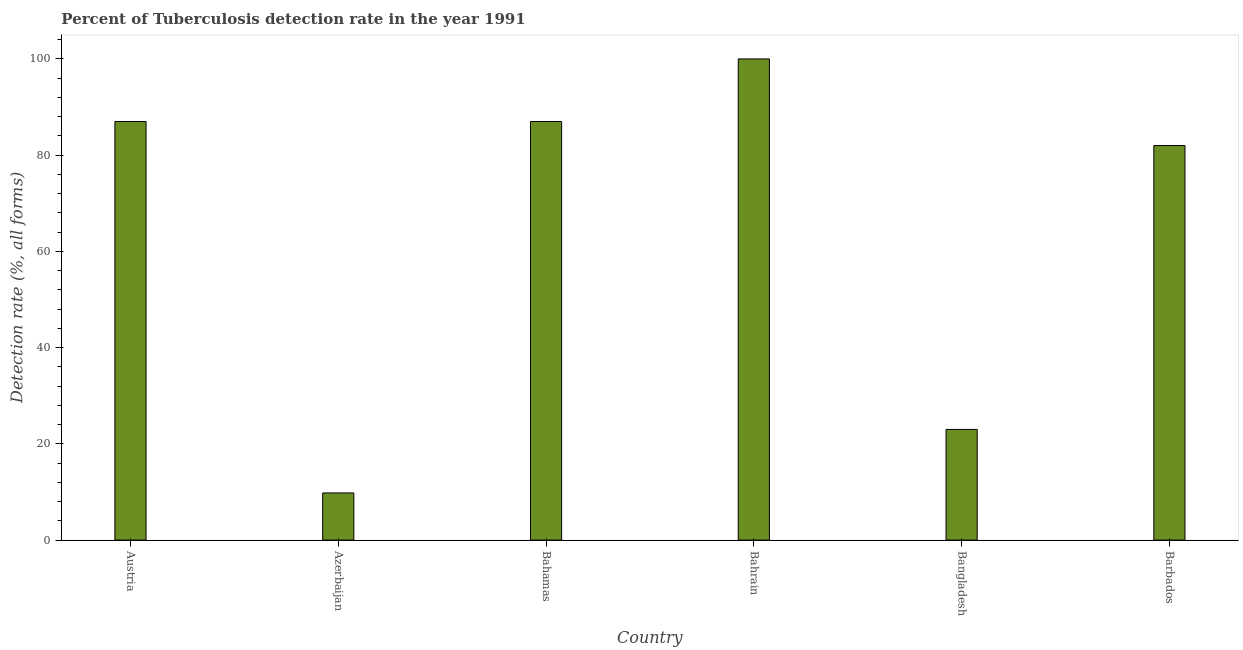What is the title of the graph?
Offer a very short reply. Percent of Tuberculosis detection rate in the year 1991. What is the label or title of the X-axis?
Provide a succinct answer. Country. What is the label or title of the Y-axis?
Ensure brevity in your answer.  Detection rate (%, all forms). Across all countries, what is the maximum detection rate of tuberculosis?
Give a very brief answer. 100. Across all countries, what is the minimum detection rate of tuberculosis?
Your response must be concise. 9.8. In which country was the detection rate of tuberculosis maximum?
Your answer should be very brief. Bahrain. In which country was the detection rate of tuberculosis minimum?
Your answer should be compact. Azerbaijan. What is the sum of the detection rate of tuberculosis?
Provide a succinct answer. 388.8. What is the difference between the detection rate of tuberculosis in Bahamas and Barbados?
Offer a very short reply. 5. What is the average detection rate of tuberculosis per country?
Make the answer very short. 64.8. What is the median detection rate of tuberculosis?
Offer a terse response. 84.5. In how many countries, is the detection rate of tuberculosis greater than 80 %?
Ensure brevity in your answer.  4. What is the ratio of the detection rate of tuberculosis in Bahamas to that in Barbados?
Your response must be concise. 1.06. Is the detection rate of tuberculosis in Azerbaijan less than that in Bahamas?
Make the answer very short. Yes. Is the difference between the detection rate of tuberculosis in Bahamas and Barbados greater than the difference between any two countries?
Provide a short and direct response. No. What is the difference between the highest and the second highest detection rate of tuberculosis?
Your answer should be very brief. 13. What is the difference between the highest and the lowest detection rate of tuberculosis?
Ensure brevity in your answer.  90.2. How many bars are there?
Offer a very short reply. 6. Are all the bars in the graph horizontal?
Provide a succinct answer. No. What is the Detection rate (%, all forms) of Bahamas?
Your response must be concise. 87. What is the Detection rate (%, all forms) of Bahrain?
Your answer should be very brief. 100. What is the difference between the Detection rate (%, all forms) in Austria and Azerbaijan?
Keep it short and to the point. 77.2. What is the difference between the Detection rate (%, all forms) in Austria and Bahrain?
Ensure brevity in your answer.  -13. What is the difference between the Detection rate (%, all forms) in Austria and Bangladesh?
Ensure brevity in your answer.  64. What is the difference between the Detection rate (%, all forms) in Austria and Barbados?
Provide a short and direct response. 5. What is the difference between the Detection rate (%, all forms) in Azerbaijan and Bahamas?
Offer a very short reply. -77.2. What is the difference between the Detection rate (%, all forms) in Azerbaijan and Bahrain?
Give a very brief answer. -90.2. What is the difference between the Detection rate (%, all forms) in Azerbaijan and Bangladesh?
Keep it short and to the point. -13.2. What is the difference between the Detection rate (%, all forms) in Azerbaijan and Barbados?
Your response must be concise. -72.2. What is the difference between the Detection rate (%, all forms) in Bahamas and Bahrain?
Give a very brief answer. -13. What is the difference between the Detection rate (%, all forms) in Bahrain and Bangladesh?
Provide a succinct answer. 77. What is the difference between the Detection rate (%, all forms) in Bangladesh and Barbados?
Make the answer very short. -59. What is the ratio of the Detection rate (%, all forms) in Austria to that in Azerbaijan?
Ensure brevity in your answer.  8.88. What is the ratio of the Detection rate (%, all forms) in Austria to that in Bahrain?
Offer a terse response. 0.87. What is the ratio of the Detection rate (%, all forms) in Austria to that in Bangladesh?
Ensure brevity in your answer.  3.78. What is the ratio of the Detection rate (%, all forms) in Austria to that in Barbados?
Give a very brief answer. 1.06. What is the ratio of the Detection rate (%, all forms) in Azerbaijan to that in Bahamas?
Keep it short and to the point. 0.11. What is the ratio of the Detection rate (%, all forms) in Azerbaijan to that in Bahrain?
Ensure brevity in your answer.  0.1. What is the ratio of the Detection rate (%, all forms) in Azerbaijan to that in Bangladesh?
Your response must be concise. 0.43. What is the ratio of the Detection rate (%, all forms) in Azerbaijan to that in Barbados?
Offer a very short reply. 0.12. What is the ratio of the Detection rate (%, all forms) in Bahamas to that in Bahrain?
Ensure brevity in your answer.  0.87. What is the ratio of the Detection rate (%, all forms) in Bahamas to that in Bangladesh?
Your answer should be compact. 3.78. What is the ratio of the Detection rate (%, all forms) in Bahamas to that in Barbados?
Make the answer very short. 1.06. What is the ratio of the Detection rate (%, all forms) in Bahrain to that in Bangladesh?
Keep it short and to the point. 4.35. What is the ratio of the Detection rate (%, all forms) in Bahrain to that in Barbados?
Your answer should be very brief. 1.22. What is the ratio of the Detection rate (%, all forms) in Bangladesh to that in Barbados?
Keep it short and to the point. 0.28. 